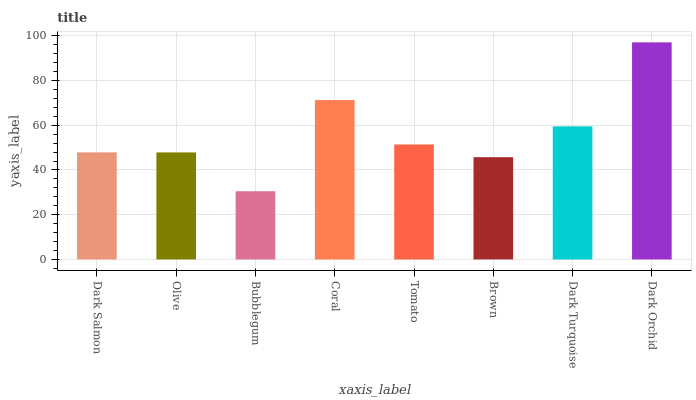Is Dark Orchid the maximum?
Answer yes or no. Yes. Is Olive the minimum?
Answer yes or no. No. Is Olive the maximum?
Answer yes or no. No. Is Dark Salmon greater than Olive?
Answer yes or no. Yes. Is Olive less than Dark Salmon?
Answer yes or no. Yes. Is Olive greater than Dark Salmon?
Answer yes or no. No. Is Dark Salmon less than Olive?
Answer yes or no. No. Is Tomato the high median?
Answer yes or no. Yes. Is Dark Salmon the low median?
Answer yes or no. Yes. Is Bubblegum the high median?
Answer yes or no. No. Is Bubblegum the low median?
Answer yes or no. No. 